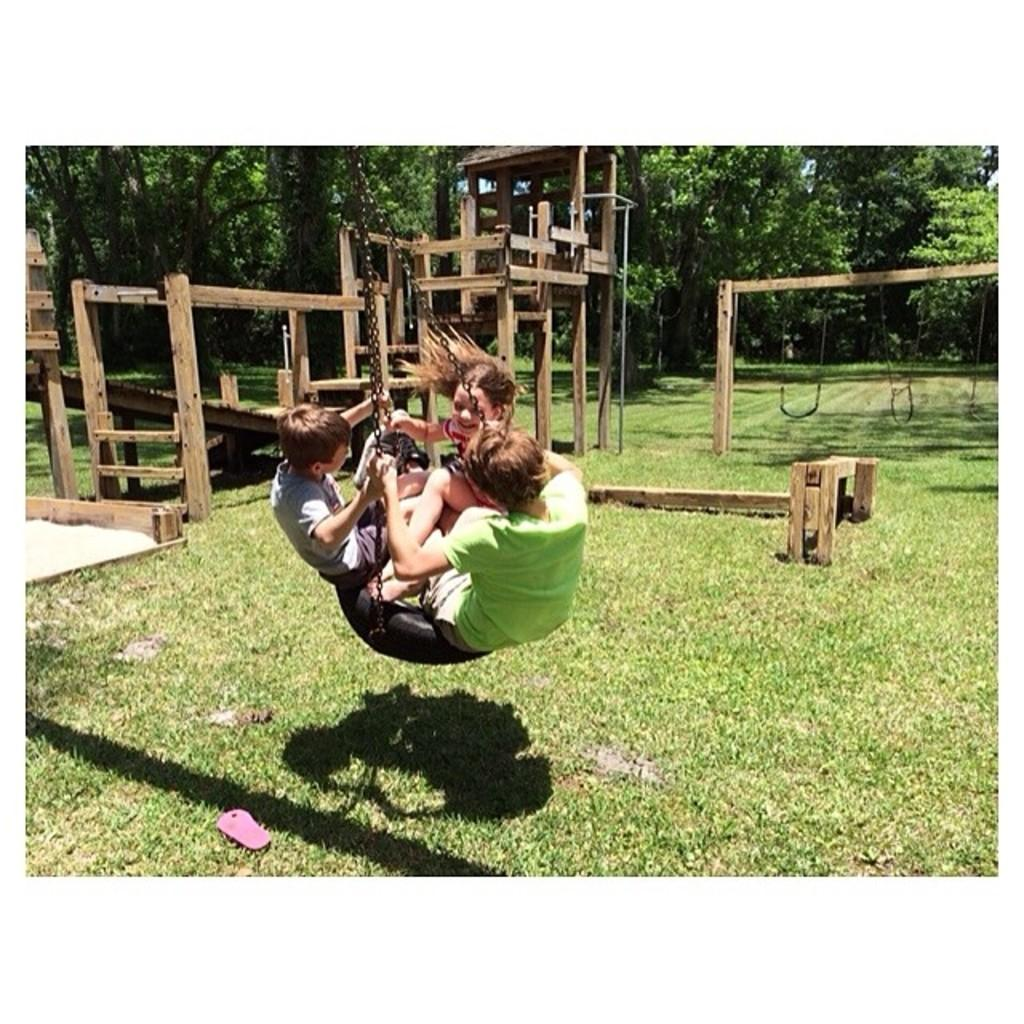How many people are in the image? There are three people in the image. What are the people doing in the image? The people are swinging in the image. What are the people holding while swinging? The people are holding chains in the image. What can be seen in the background of the image? There are wooden objects, swings, and trees in the background of the image. What type of shade is provided by the giants in the image? There are no giants present in the image, so there is no shade provided by them. What material are the swings made of in the image? The swings in the image are made of wood, as mentioned in the background description. 